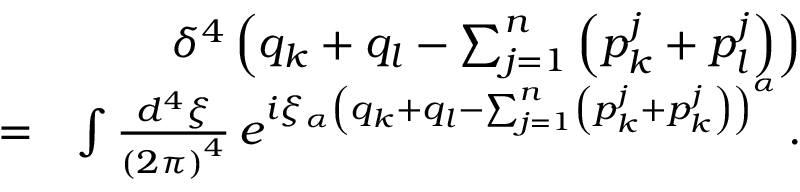<formula> <loc_0><loc_0><loc_500><loc_500>\begin{array} { r l r } & { \delta ^ { 4 } \left ( q _ { k } + q _ { l } - \sum _ { j = 1 } ^ { n } \left ( p _ { k } ^ { j } + p _ { l } ^ { j } \right ) \right ) } \\ & { = } & { \int \frac { d ^ { 4 } \xi } { \left ( 2 \pi \right ) ^ { 4 } } \, e ^ { i \xi _ { \alpha } \left ( q _ { k } + q _ { l } - \sum _ { j = 1 } ^ { n } \left ( p _ { k } ^ { j } + p _ { k } ^ { j } \right ) \right ) ^ { \alpha } } \, . } \end{array}</formula> 